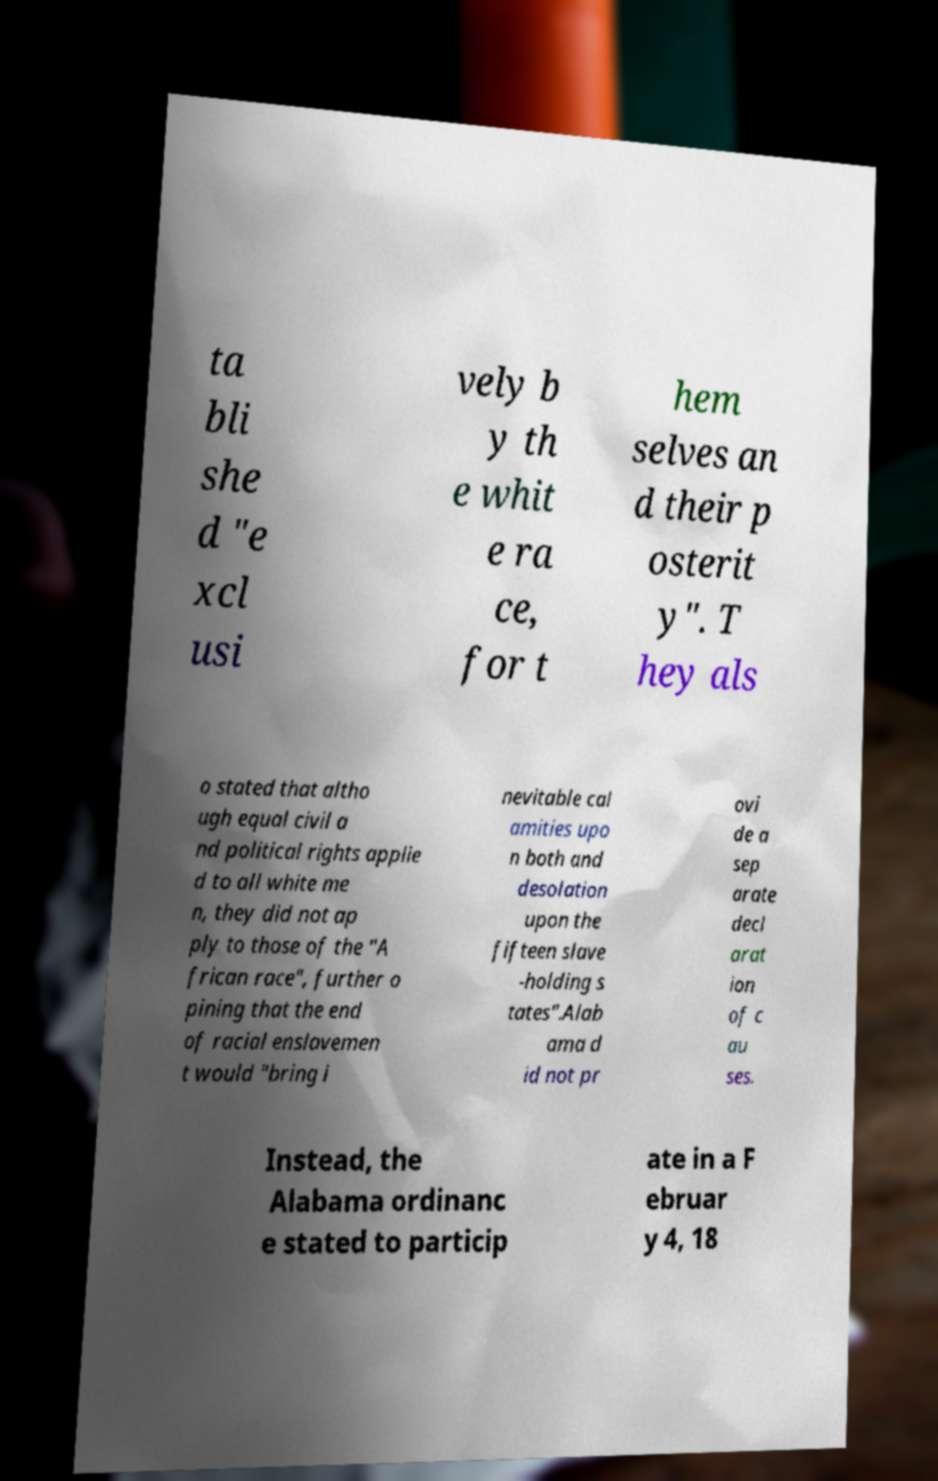There's text embedded in this image that I need extracted. Can you transcribe it verbatim? ta bli she d "e xcl usi vely b y th e whit e ra ce, for t hem selves an d their p osterit y". T hey als o stated that altho ugh equal civil a nd political rights applie d to all white me n, they did not ap ply to those of the "A frican race", further o pining that the end of racial enslavemen t would "bring i nevitable cal amities upo n both and desolation upon the fifteen slave -holding s tates".Alab ama d id not pr ovi de a sep arate decl arat ion of c au ses. Instead, the Alabama ordinanc e stated to particip ate in a F ebruar y 4, 18 